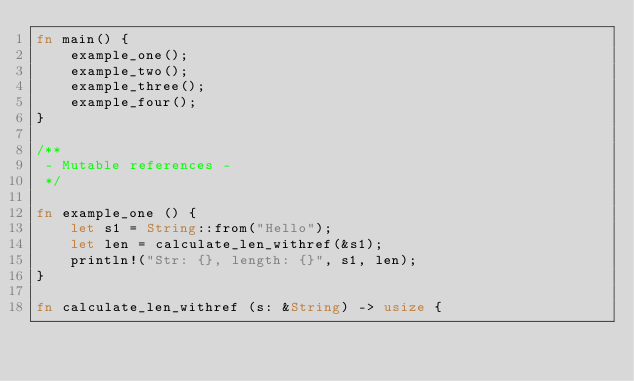Convert code to text. <code><loc_0><loc_0><loc_500><loc_500><_Rust_>fn main() {
    example_one();
    example_two();
    example_three();
    example_four();
}

/**
 - Mutable references -
 */

fn example_one () {
    let s1 = String::from("Hello");
    let len = calculate_len_withref(&s1);
    println!("Str: {}, length: {}", s1, len);
}

fn calculate_len_withref (s: &String) -> usize {</code> 